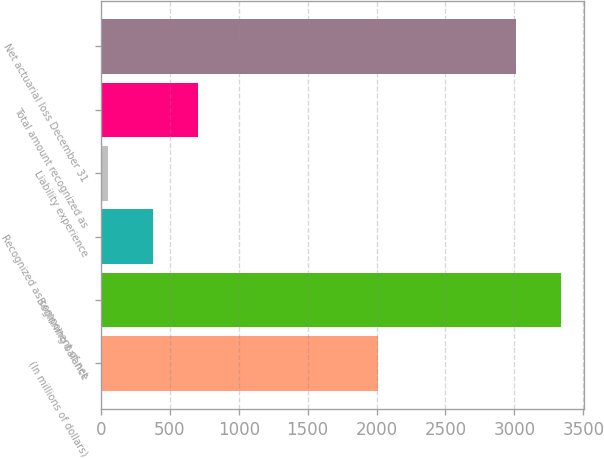Convert chart to OTSL. <chart><loc_0><loc_0><loc_500><loc_500><bar_chart><fcel>(In millions of dollars)<fcel>Beginning balance<fcel>Recognized as component of net<fcel>Liability experience<fcel>Total amount recognized as<fcel>Net actuarial loss December 31<nl><fcel>2013<fcel>3335.6<fcel>378.6<fcel>53<fcel>704.2<fcel>3010<nl></chart> 